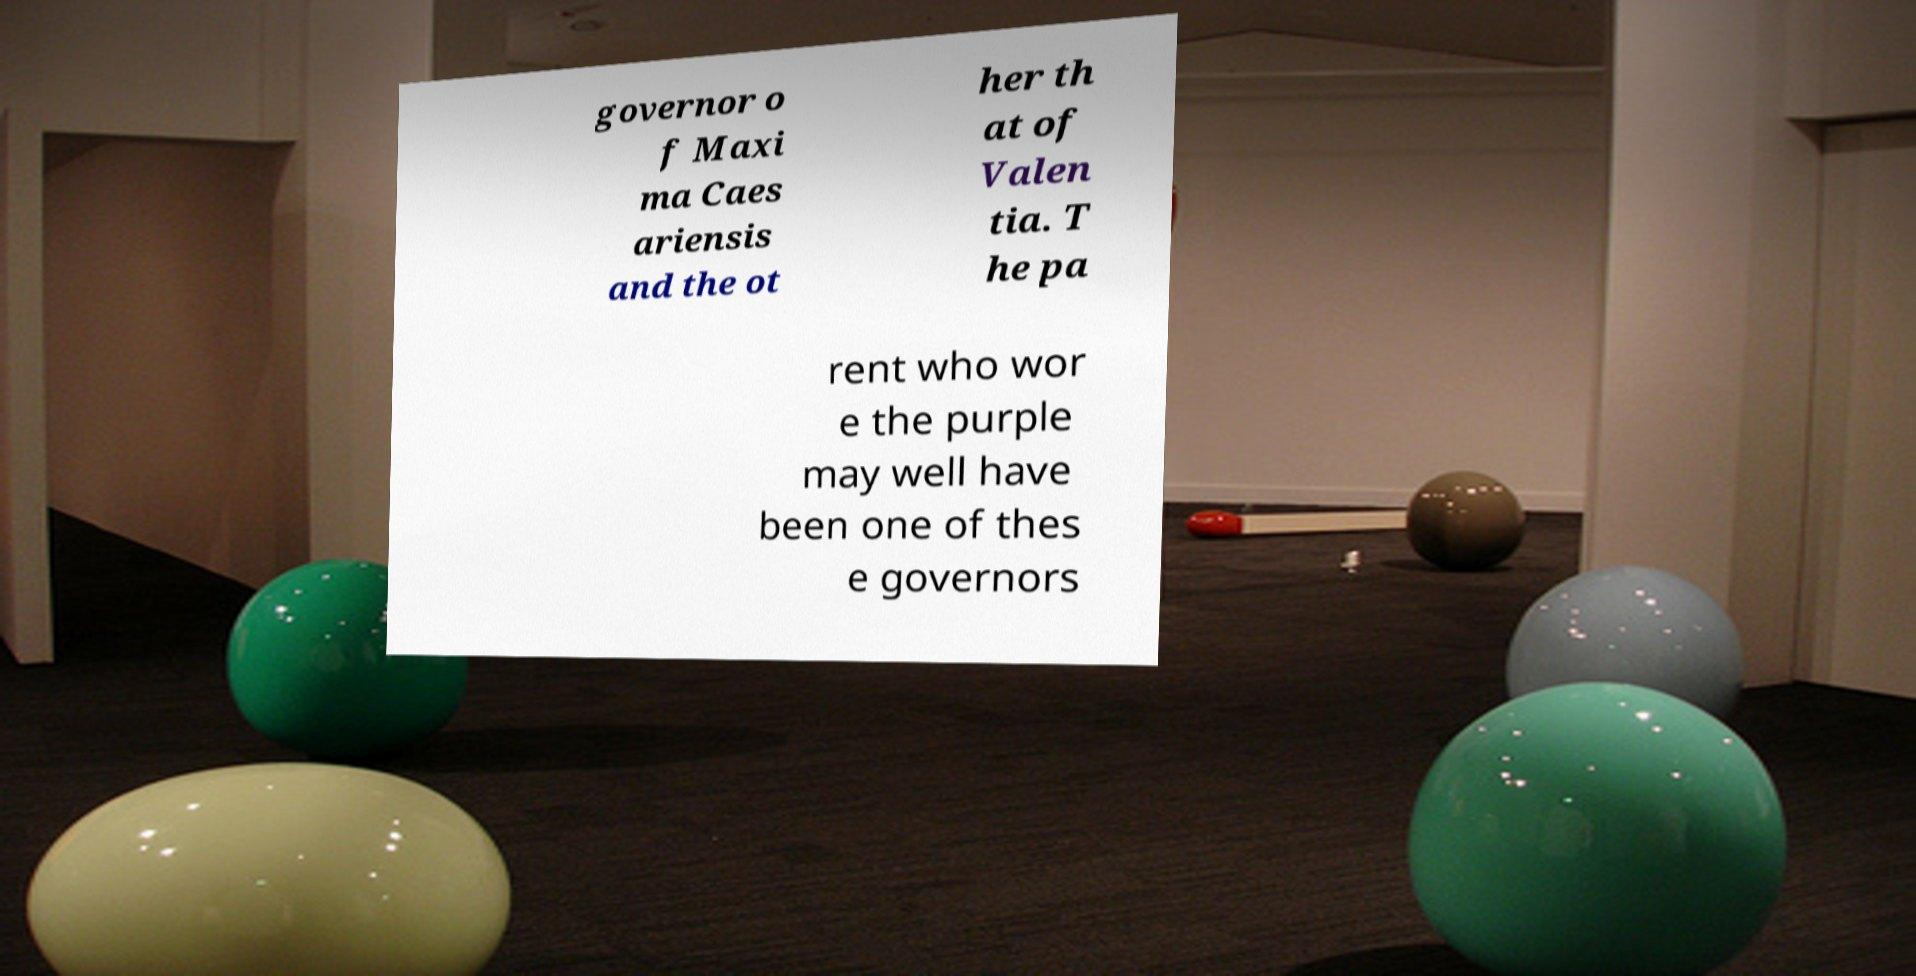Could you extract and type out the text from this image? governor o f Maxi ma Caes ariensis and the ot her th at of Valen tia. T he pa rent who wor e the purple may well have been one of thes e governors 